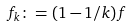<formula> <loc_0><loc_0><loc_500><loc_500>f _ { k } \colon = ( 1 - 1 / k ) f</formula> 